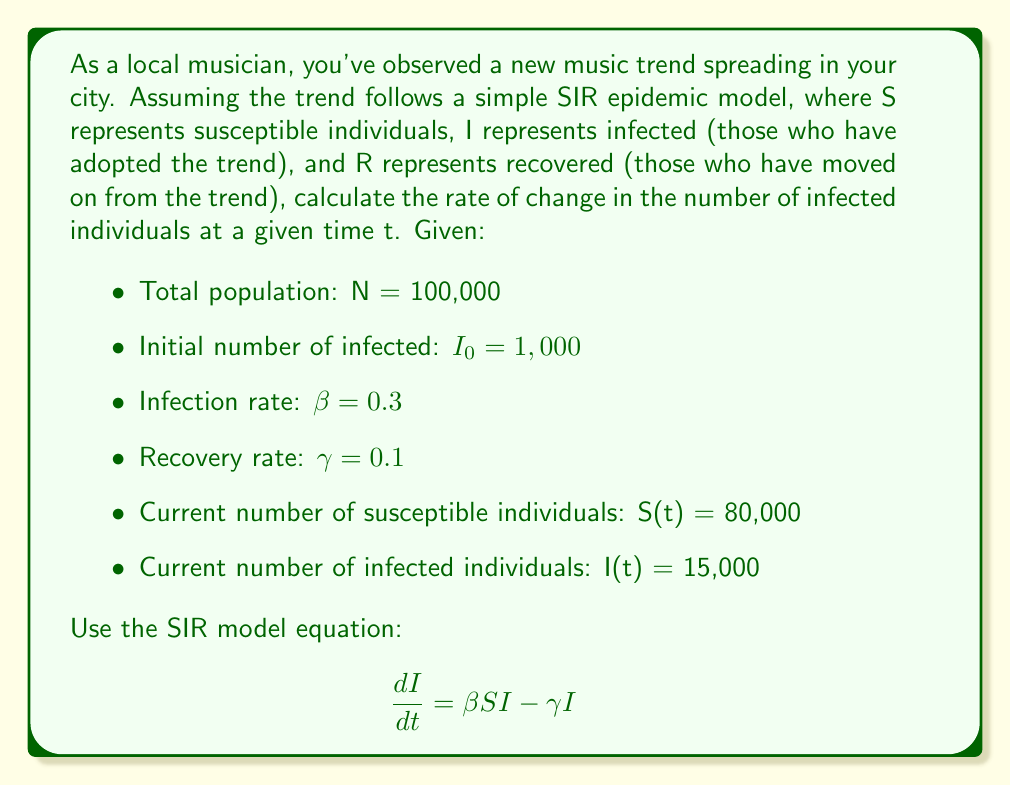Show me your answer to this math problem. To solve this problem, we'll follow these steps:

1) Recall the SIR model equation for the rate of change of infected individuals:

   $$\frac{dI}{dt} = \beta SI - \gamma I$$

2) We're given the following values:
   - $\beta = 0.3$
   - $\gamma = 0.1$
   - S(t) = 80,000
   - I(t) = 15,000

3) Substitute these values into the equation:

   $$\frac{dI}{dt} = (0.3)(80,000)(15,000) - (0.1)(15,000)$$

4) Simplify:
   $$\frac{dI}{dt} = 360,000,000 - 1,500$$

5) Calculate the final result:
   $$\frac{dI}{dt} = 359,998,500$$

This result represents the rate of change in the number of individuals adopting the music trend at the given time t. The positive value indicates that the trend is still growing in popularity.
Answer: 359,998,500 individuals per unit time 